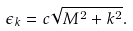Convert formula to latex. <formula><loc_0><loc_0><loc_500><loc_500>\epsilon _ { k } = c \sqrt { M ^ { 2 } + k ^ { 2 } } .</formula> 